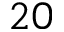Convert formula to latex. <formula><loc_0><loc_0><loc_500><loc_500>2 0</formula> 